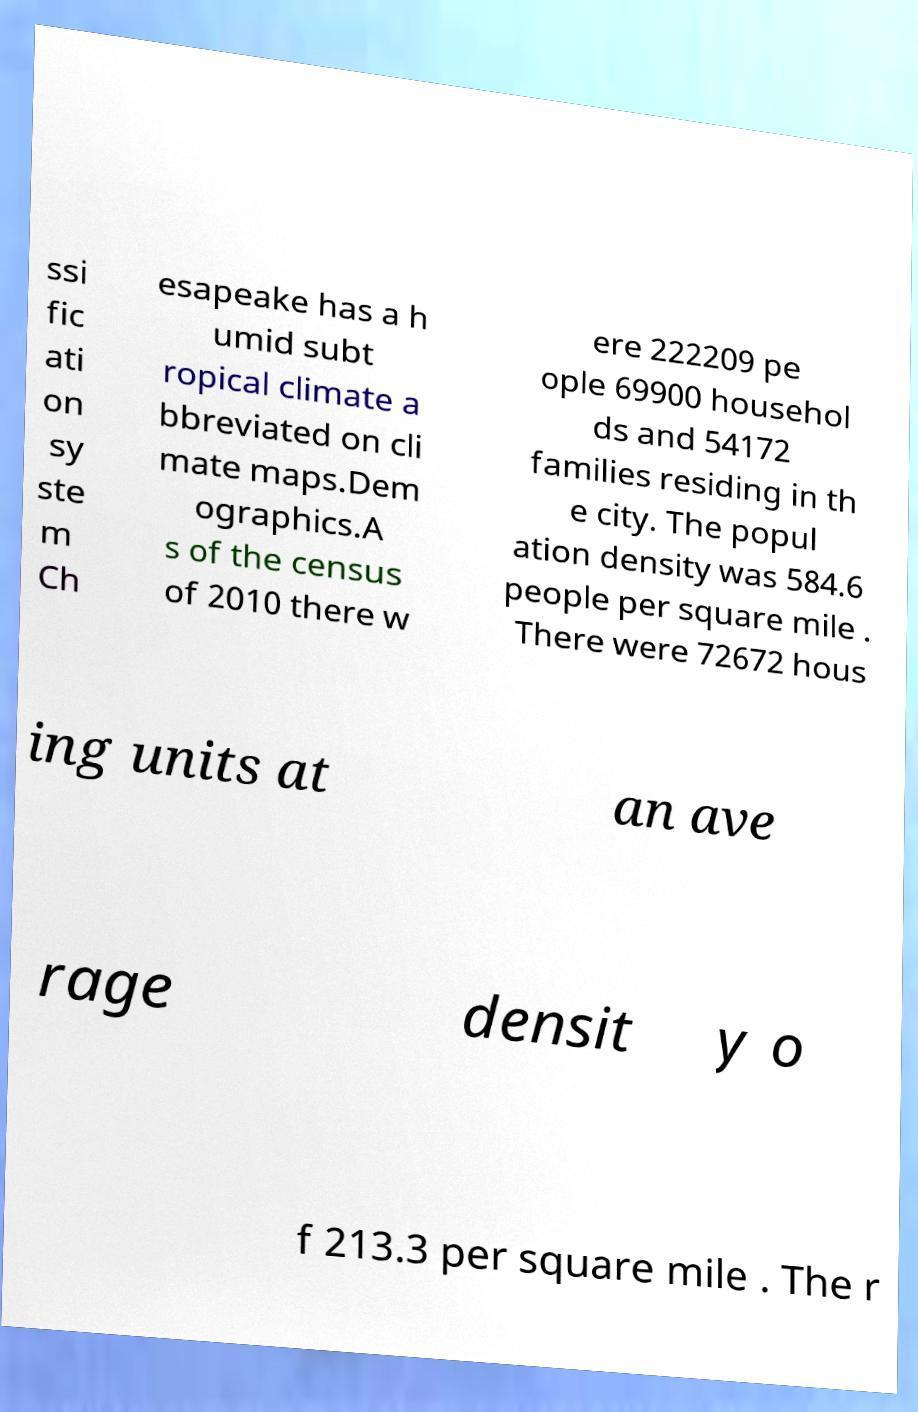Could you assist in decoding the text presented in this image and type it out clearly? ssi fic ati on sy ste m Ch esapeake has a h umid subt ropical climate a bbreviated on cli mate maps.Dem ographics.A s of the census of 2010 there w ere 222209 pe ople 69900 househol ds and 54172 families residing in th e city. The popul ation density was 584.6 people per square mile . There were 72672 hous ing units at an ave rage densit y o f 213.3 per square mile . The r 